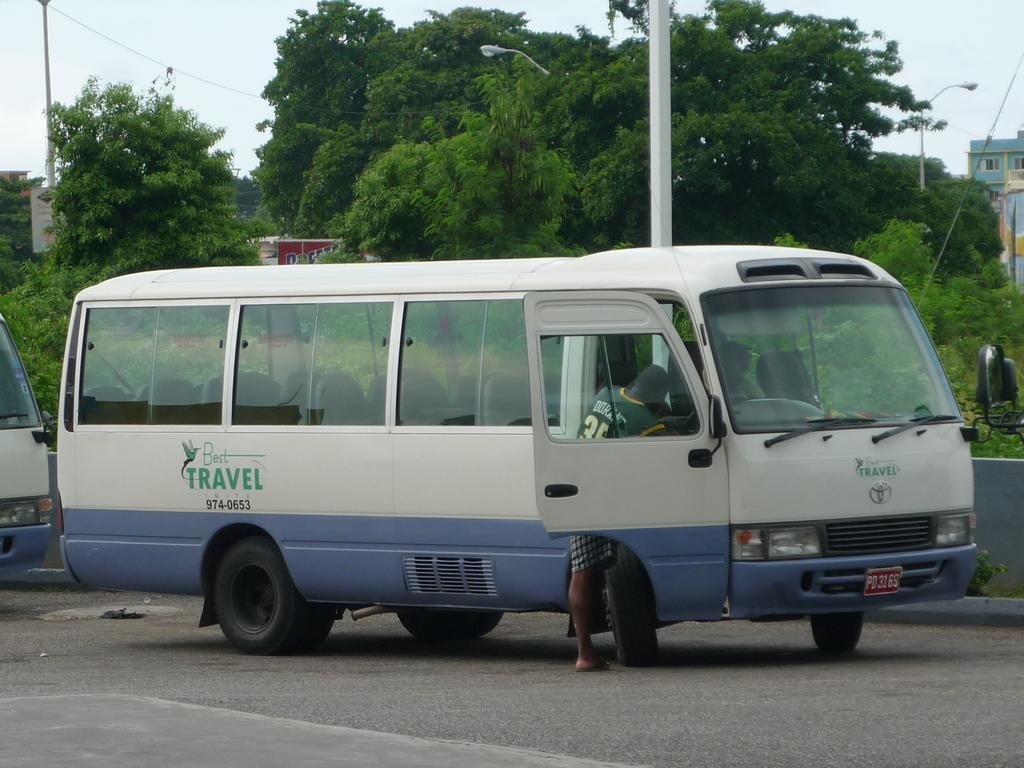<image>
Describe the image concisely. a travel bus that is blue and white 